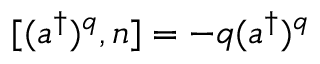Convert formula to latex. <formula><loc_0><loc_0><loc_500><loc_500>[ ( a ^ { \dagger } ) ^ { q } , n ] = - q ( a ^ { \dagger } ) ^ { q }</formula> 